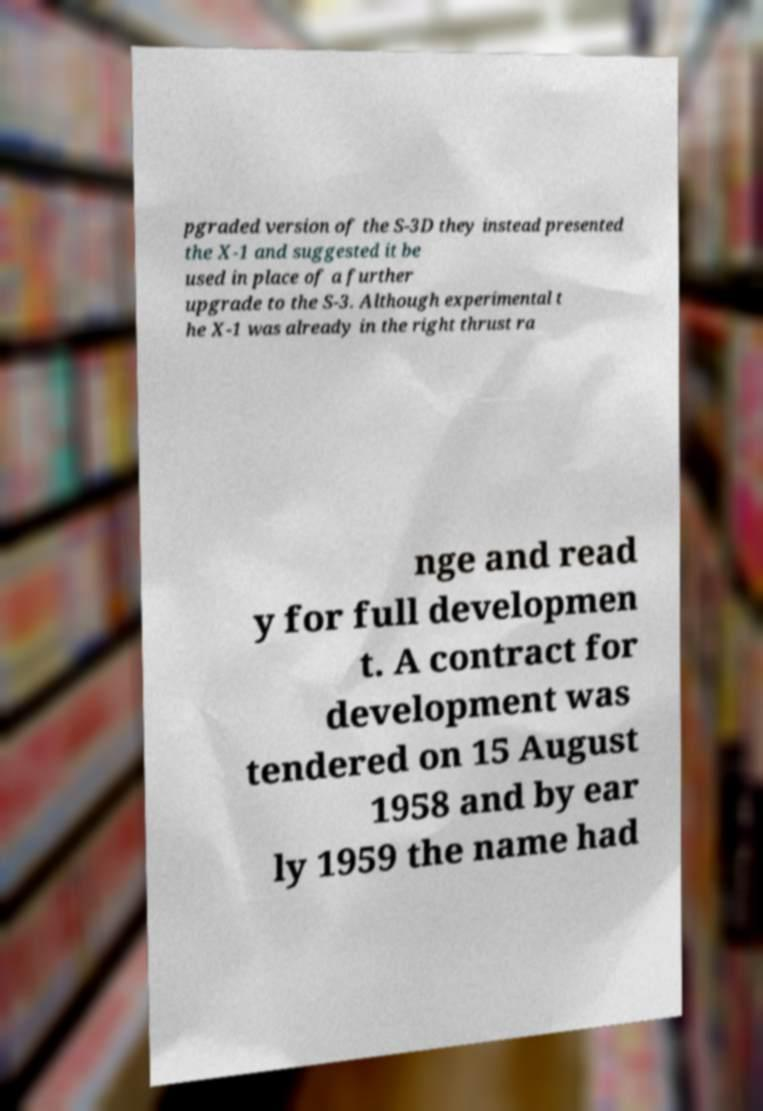I need the written content from this picture converted into text. Can you do that? pgraded version of the S-3D they instead presented the X-1 and suggested it be used in place of a further upgrade to the S-3. Although experimental t he X-1 was already in the right thrust ra nge and read y for full developmen t. A contract for development was tendered on 15 August 1958 and by ear ly 1959 the name had 